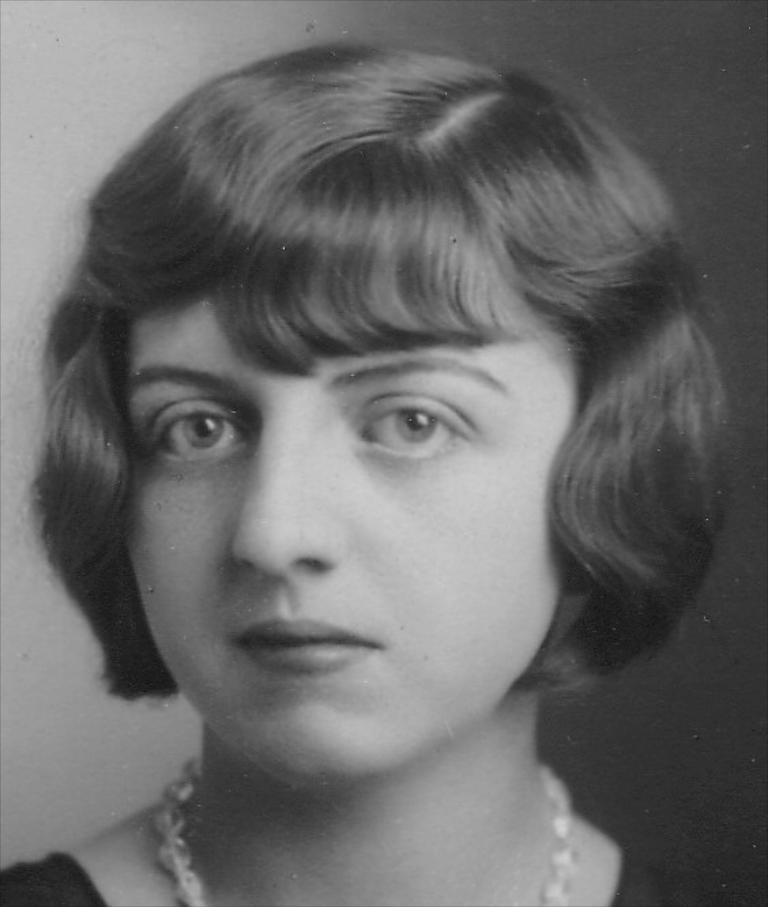What is the color scheme of the image? The image is black and white. Can you describe the main subject in the image? There is a woman in the image. What can be observed about the background in the image? The background behind the woman is blurred. What type of cap is the woman wearing in the image? There is no cap visible in the image, as it is in black and white and does not show any clothing details. 